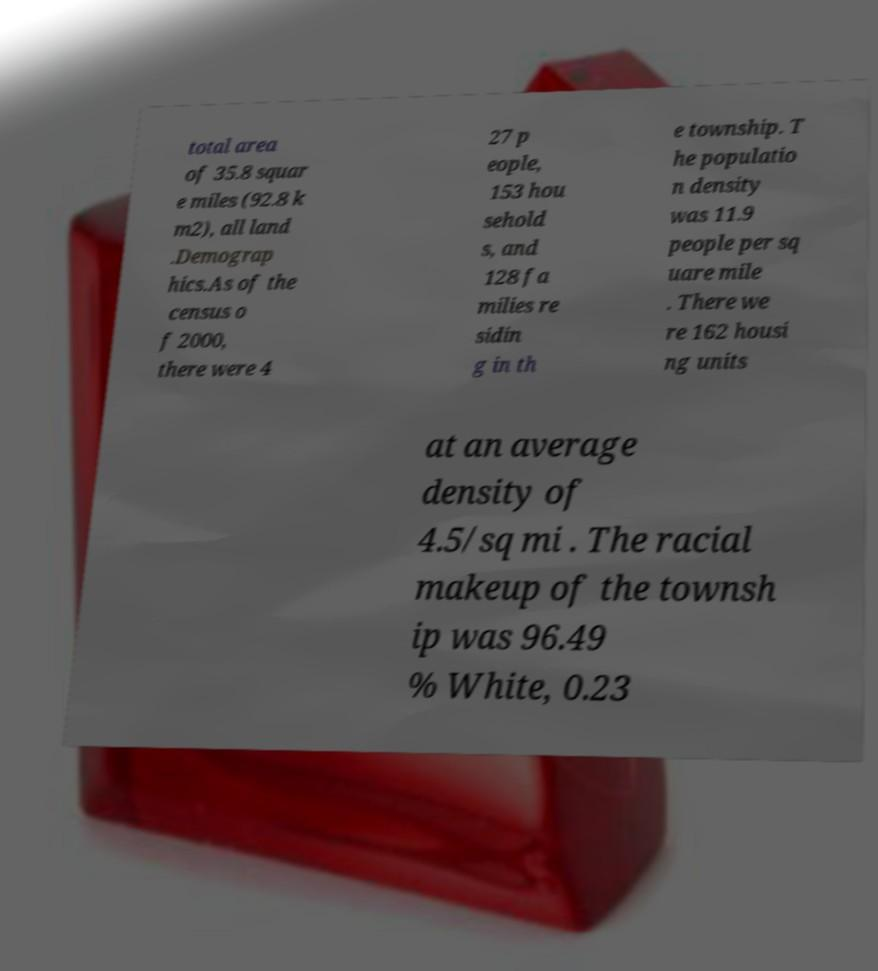I need the written content from this picture converted into text. Can you do that? total area of 35.8 squar e miles (92.8 k m2), all land .Demograp hics.As of the census o f 2000, there were 4 27 p eople, 153 hou sehold s, and 128 fa milies re sidin g in th e township. T he populatio n density was 11.9 people per sq uare mile . There we re 162 housi ng units at an average density of 4.5/sq mi . The racial makeup of the townsh ip was 96.49 % White, 0.23 